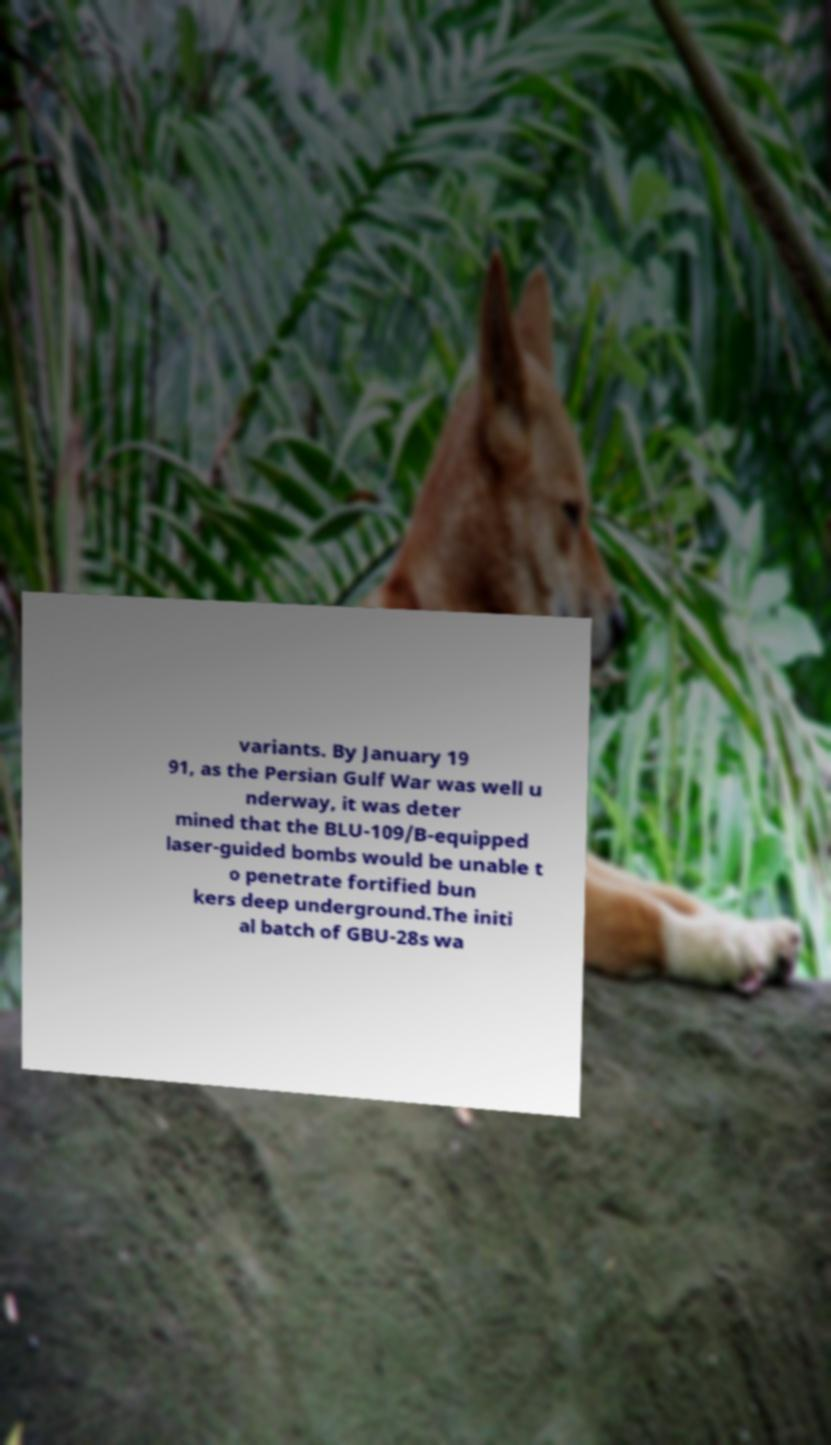Please read and relay the text visible in this image. What does it say? variants. By January 19 91, as the Persian Gulf War was well u nderway, it was deter mined that the BLU-109/B-equipped laser-guided bombs would be unable t o penetrate fortified bun kers deep underground.The initi al batch of GBU-28s wa 